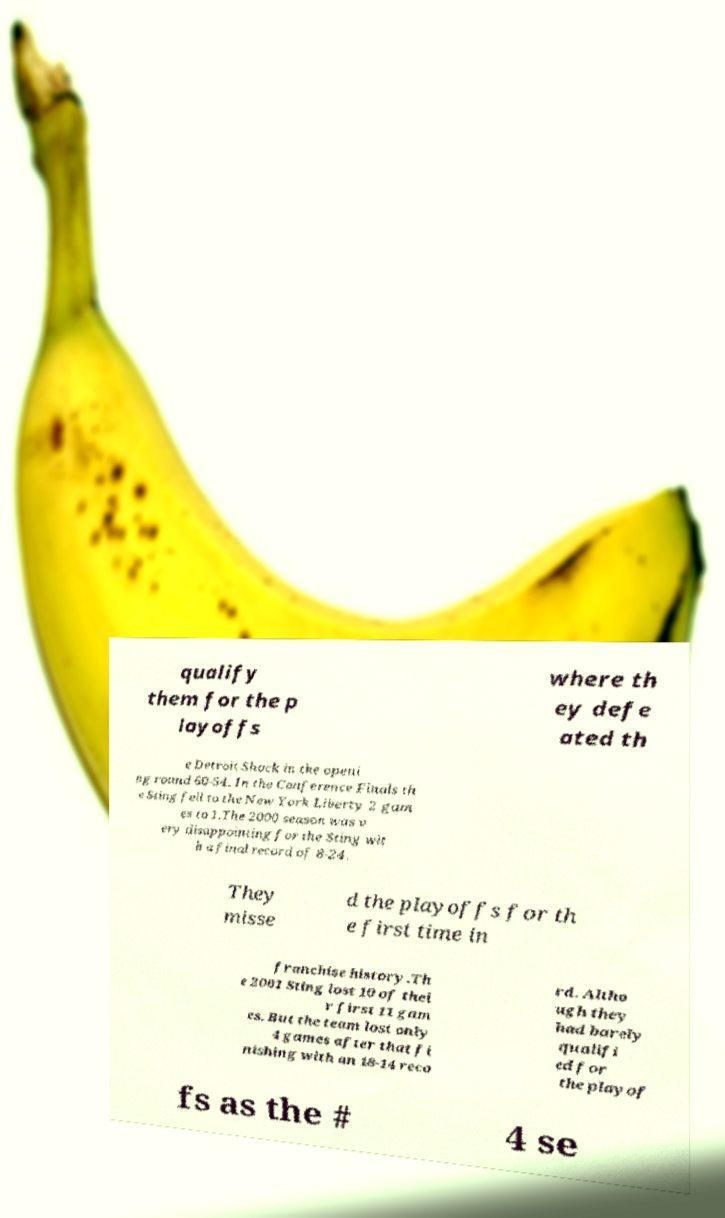What messages or text are displayed in this image? I need them in a readable, typed format. qualify them for the p layoffs where th ey defe ated th e Detroit Shock in the openi ng round 60-54. In the Conference Finals th e Sting fell to the New York Liberty 2 gam es to 1.The 2000 season was v ery disappointing for the Sting wit h a final record of 8-24. They misse d the playoffs for th e first time in franchise history.Th e 2001 Sting lost 10 of thei r first 11 gam es. But the team lost only 4 games after that fi nishing with an 18-14 reco rd. Altho ugh they had barely qualifi ed for the playof fs as the # 4 se 